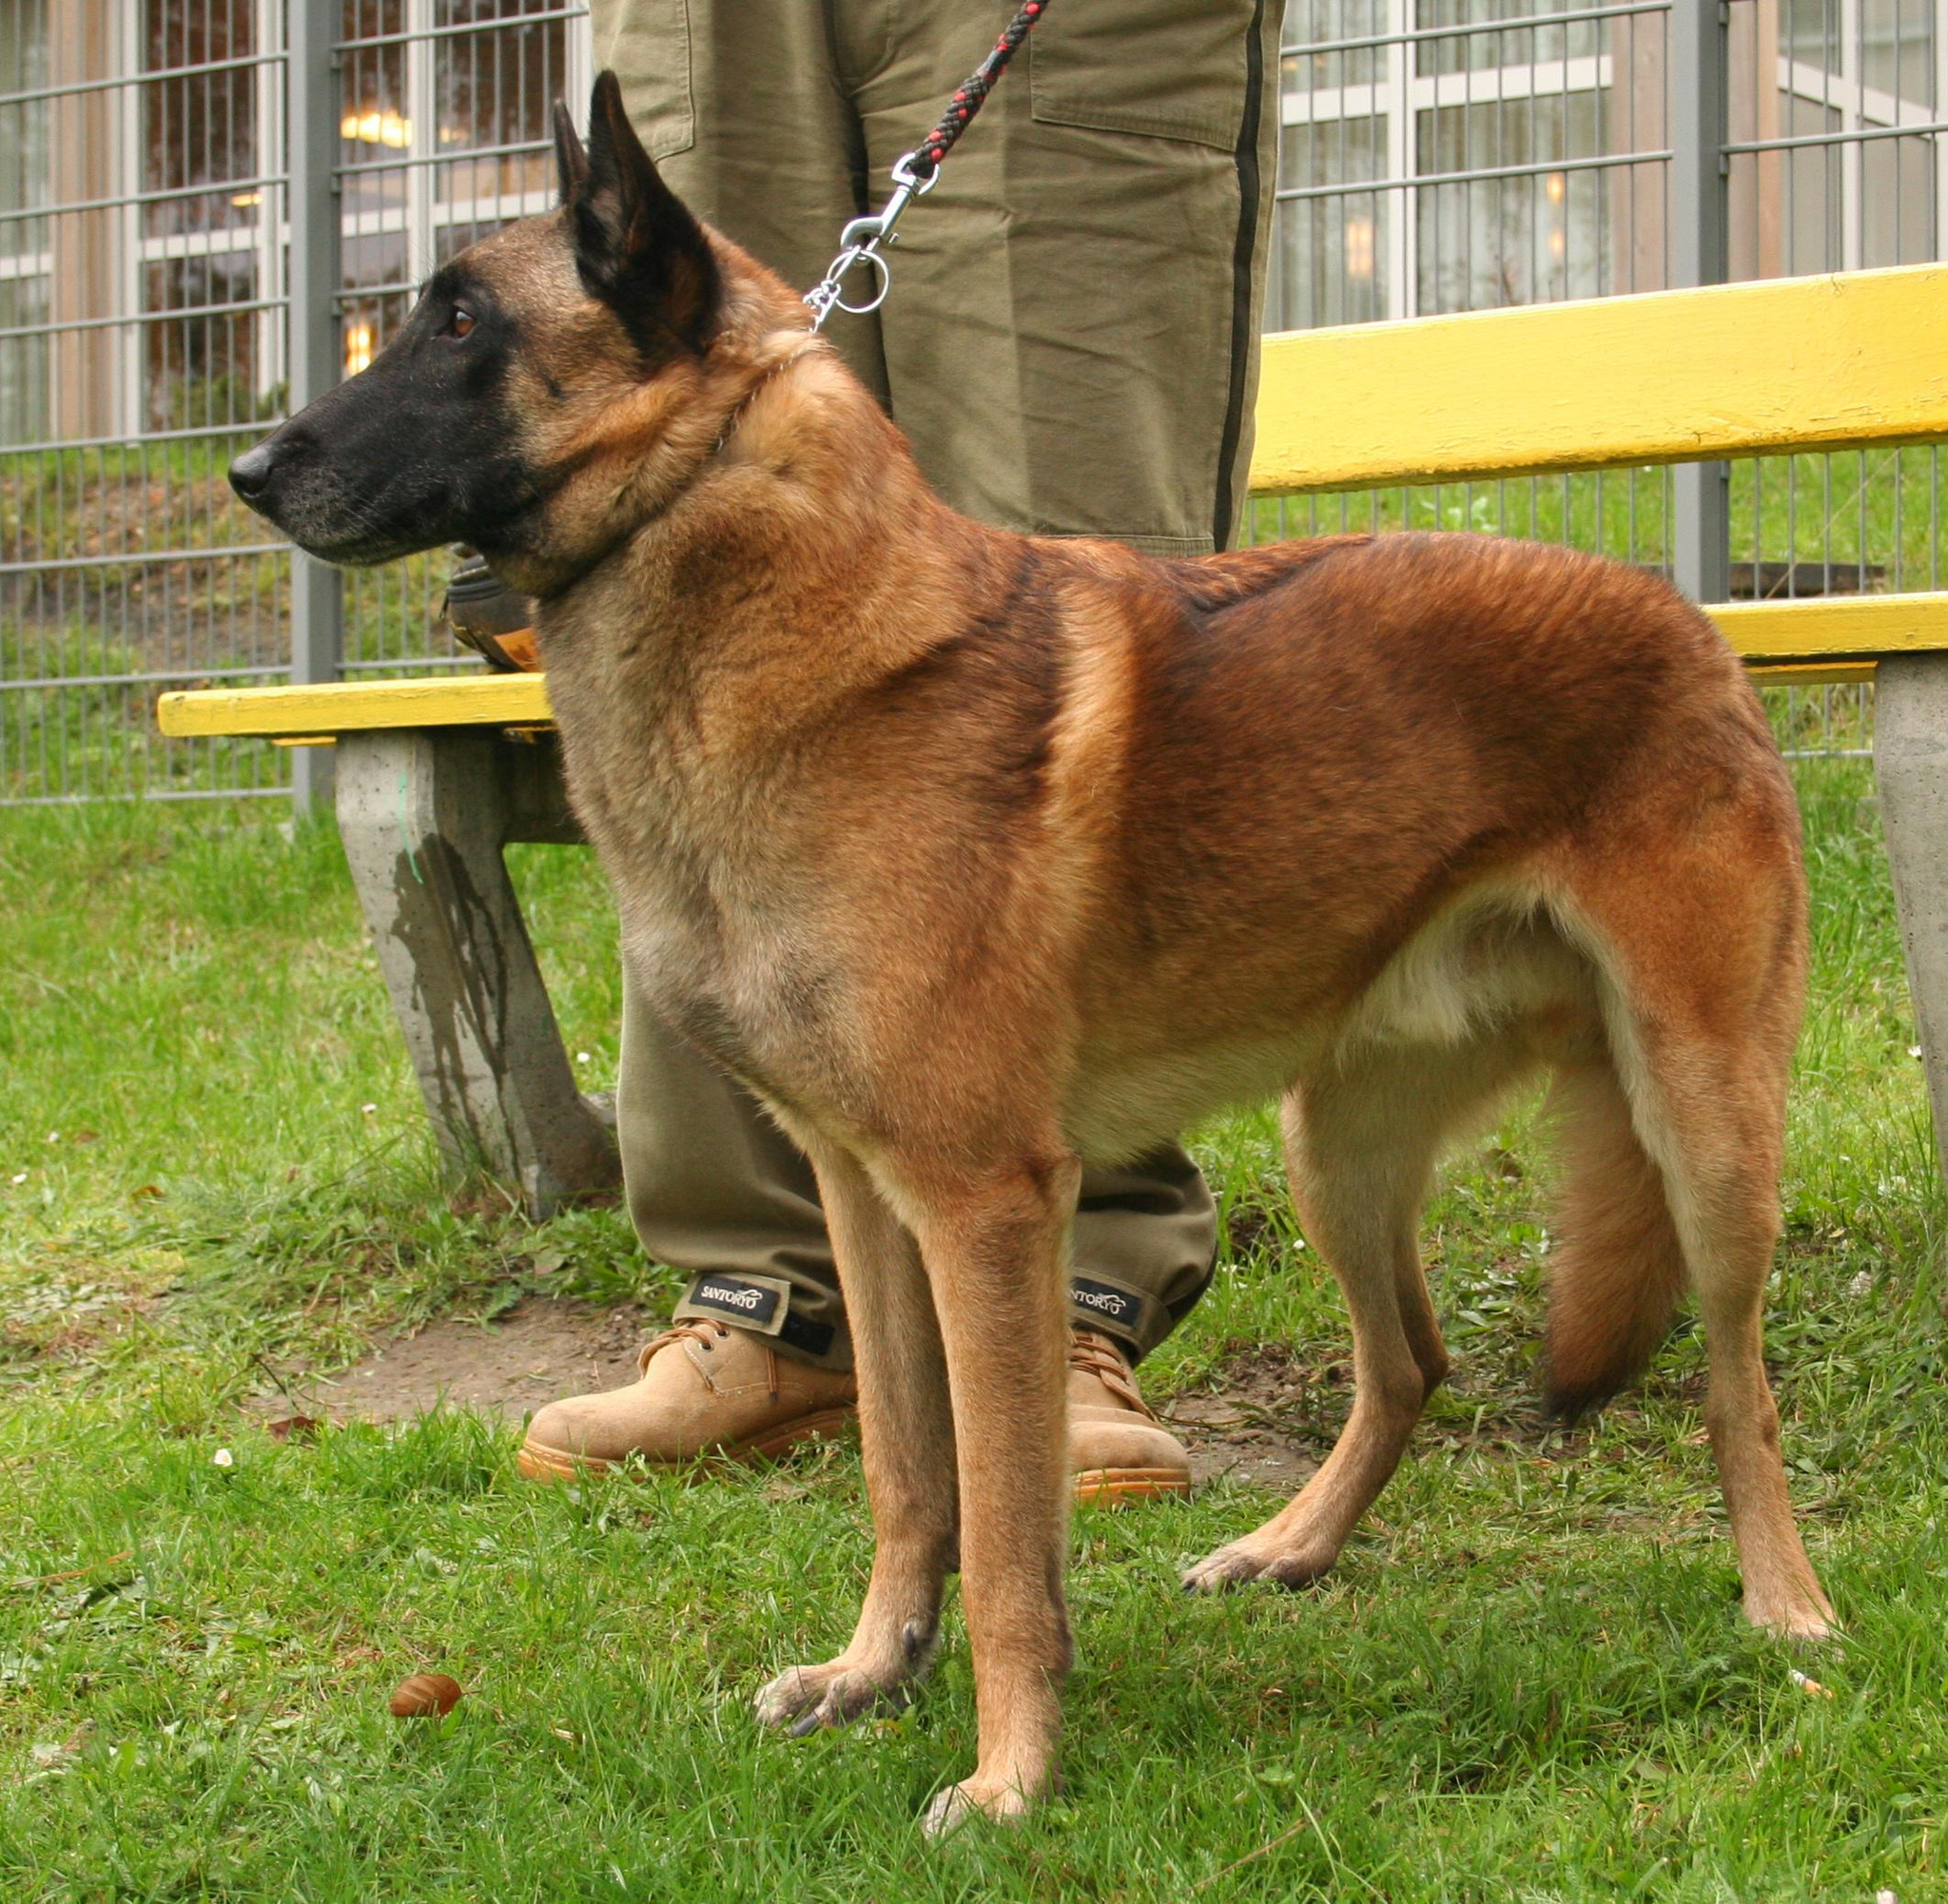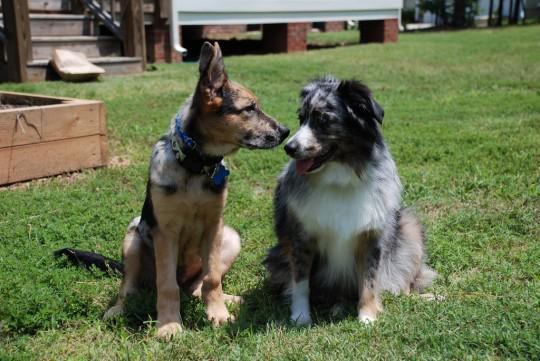The first image is the image on the left, the second image is the image on the right. Assess this claim about the two images: "Every photograph shows exactly three German Shepard dogs photographed outside, with at least two dogs on the left hand side sticking their tongues out.". Correct or not? Answer yes or no. No. The first image is the image on the left, the second image is the image on the right. Examine the images to the left and right. Is the description "There is exactly three dogs in the left image." accurate? Answer yes or no. No. 